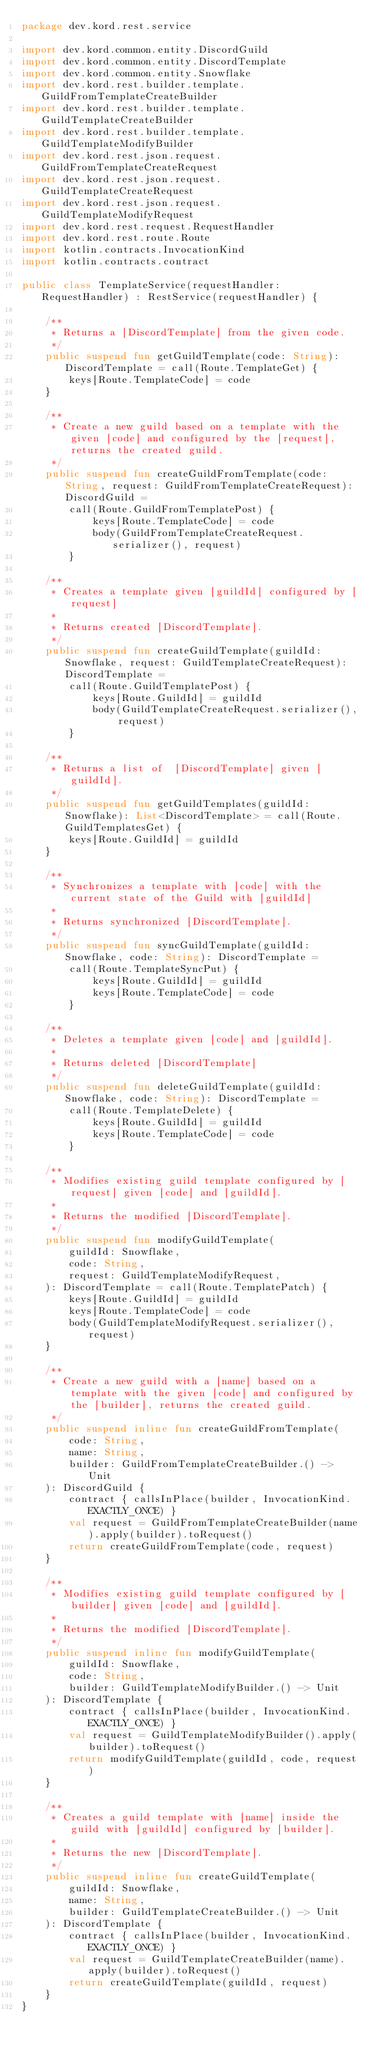Convert code to text. <code><loc_0><loc_0><loc_500><loc_500><_Kotlin_>package dev.kord.rest.service

import dev.kord.common.entity.DiscordGuild
import dev.kord.common.entity.DiscordTemplate
import dev.kord.common.entity.Snowflake
import dev.kord.rest.builder.template.GuildFromTemplateCreateBuilder
import dev.kord.rest.builder.template.GuildTemplateCreateBuilder
import dev.kord.rest.builder.template.GuildTemplateModifyBuilder
import dev.kord.rest.json.request.GuildFromTemplateCreateRequest
import dev.kord.rest.json.request.GuildTemplateCreateRequest
import dev.kord.rest.json.request.GuildTemplateModifyRequest
import dev.kord.rest.request.RequestHandler
import dev.kord.rest.route.Route
import kotlin.contracts.InvocationKind
import kotlin.contracts.contract

public class TemplateService(requestHandler: RequestHandler) : RestService(requestHandler) {

    /**
     * Returns a [DiscordTemplate] from the given code.
     */
    public suspend fun getGuildTemplate(code: String): DiscordTemplate = call(Route.TemplateGet) {
        keys[Route.TemplateCode] = code
    }

    /**
     * Create a new guild based on a template with the given [code] and configured by the [request], returns the created guild.
     */
    public suspend fun createGuildFromTemplate(code: String, request: GuildFromTemplateCreateRequest): DiscordGuild =
        call(Route.GuildFromTemplatePost) {
            keys[Route.TemplateCode] = code
            body(GuildFromTemplateCreateRequest.serializer(), request)
        }

    /**
     * Creates a template given [guildId] configured by [request]
     *
     * Returns created [DiscordTemplate].
     */
    public suspend fun createGuildTemplate(guildId: Snowflake, request: GuildTemplateCreateRequest): DiscordTemplate =
        call(Route.GuildTemplatePost) {
            keys[Route.GuildId] = guildId
            body(GuildTemplateCreateRequest.serializer(), request)
        }

    /**
     * Returns a list of  [DiscordTemplate] given [guildId].
     */
    public suspend fun getGuildTemplates(guildId: Snowflake): List<DiscordTemplate> = call(Route.GuildTemplatesGet) {
        keys[Route.GuildId] = guildId
    }

    /**
     * Synchronizes a template with [code] with the current state of the Guild with [guildId]
     *
     * Returns synchronized [DiscordTemplate].
     */
    public suspend fun syncGuildTemplate(guildId: Snowflake, code: String): DiscordTemplate =
        call(Route.TemplateSyncPut) {
            keys[Route.GuildId] = guildId
            keys[Route.TemplateCode] = code
        }

    /**
     * Deletes a template given [code] and [guildId].
     *
     * Returns deleted [DiscordTemplate]
     */
    public suspend fun deleteGuildTemplate(guildId: Snowflake, code: String): DiscordTemplate =
        call(Route.TemplateDelete) {
            keys[Route.GuildId] = guildId
            keys[Route.TemplateCode] = code
        }

    /**
     * Modifies existing guild template configured by [request] given [code] and [guildId].
     *
     * Returns the modified [DiscordTemplate].
     */
    public suspend fun modifyGuildTemplate(
        guildId: Snowflake,
        code: String,
        request: GuildTemplateModifyRequest,
    ): DiscordTemplate = call(Route.TemplatePatch) {
        keys[Route.GuildId] = guildId
        keys[Route.TemplateCode] = code
        body(GuildTemplateModifyRequest.serializer(), request)
    }

    /**
     * Create a new guild with a [name] based on a template with the given [code] and configured by the [builder], returns the created guild.
     */
    public suspend inline fun createGuildFromTemplate(
        code: String,
        name: String,
        builder: GuildFromTemplateCreateBuilder.() -> Unit
    ): DiscordGuild {
        contract { callsInPlace(builder, InvocationKind.EXACTLY_ONCE) }
        val request = GuildFromTemplateCreateBuilder(name).apply(builder).toRequest()
        return createGuildFromTemplate(code, request)
    }

    /**
     * Modifies existing guild template configured by [builder] given [code] and [guildId].
     *
     * Returns the modified [DiscordTemplate].
     */
    public suspend inline fun modifyGuildTemplate(
        guildId: Snowflake,
        code: String,
        builder: GuildTemplateModifyBuilder.() -> Unit
    ): DiscordTemplate {
        contract { callsInPlace(builder, InvocationKind.EXACTLY_ONCE) }
        val request = GuildTemplateModifyBuilder().apply(builder).toRequest()
        return modifyGuildTemplate(guildId, code, request)
    }

    /**
     * Creates a guild template with [name] inside the guild with [guildId] configured by [builder].
     *
     * Returns the new [DiscordTemplate].
     */
    public suspend inline fun createGuildTemplate(
        guildId: Snowflake,
        name: String,
        builder: GuildTemplateCreateBuilder.() -> Unit
    ): DiscordTemplate {
        contract { callsInPlace(builder, InvocationKind.EXACTLY_ONCE) }
        val request = GuildTemplateCreateBuilder(name).apply(builder).toRequest()
        return createGuildTemplate(guildId, request)
    }
}
</code> 